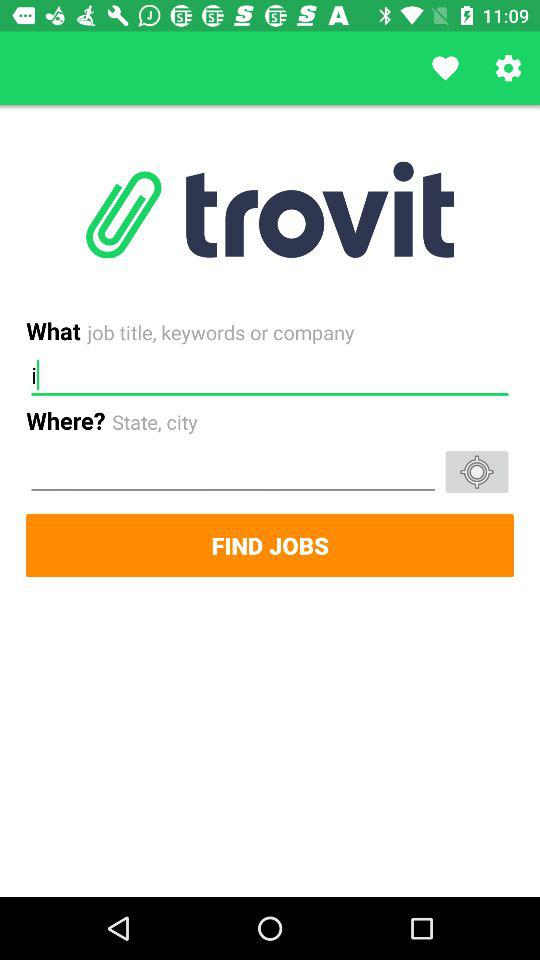What is the time given for sunrise? The time given for sunrise is 09:14. 